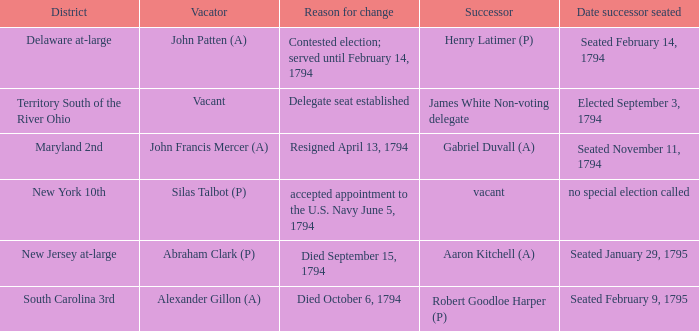On which date was the successor seated for the delegate seat that was created? Elected September 3, 1794. 